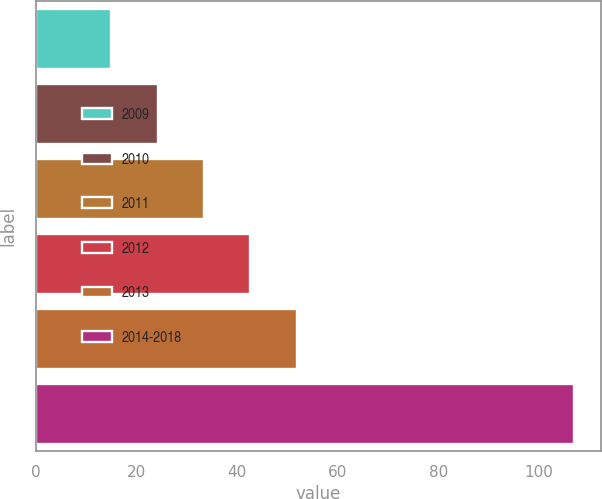<chart> <loc_0><loc_0><loc_500><loc_500><bar_chart><fcel>2009<fcel>2010<fcel>2011<fcel>2012<fcel>2013<fcel>2014-2018<nl><fcel>15<fcel>24.2<fcel>33.4<fcel>42.6<fcel>51.8<fcel>107<nl></chart> 